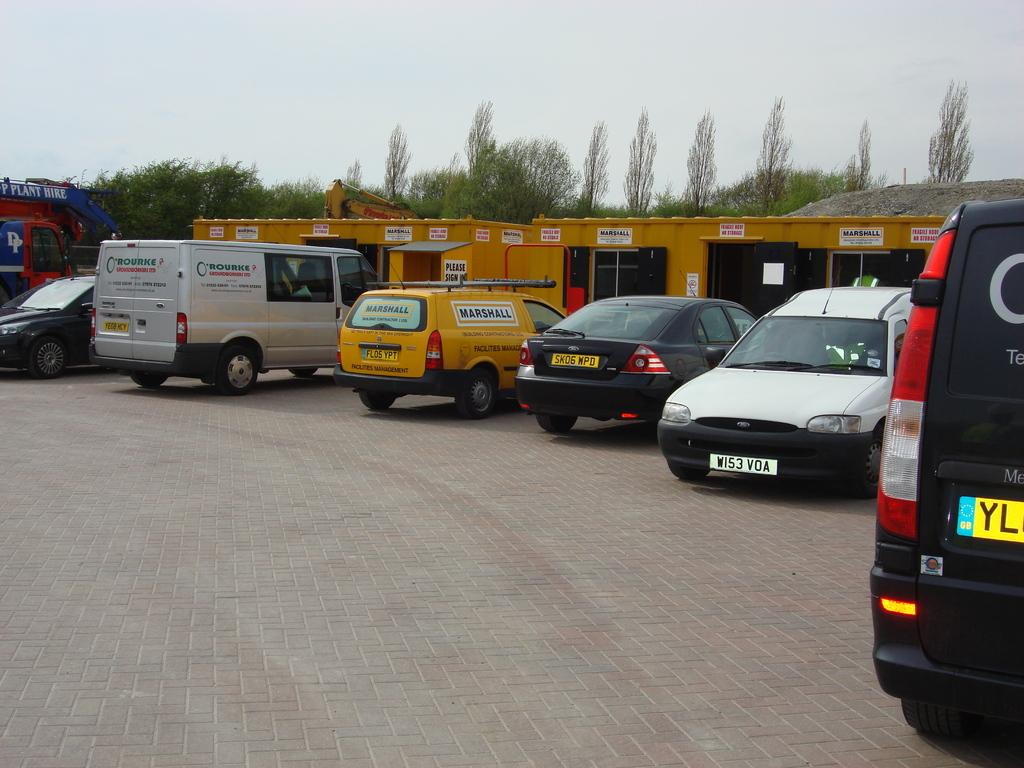<image>
Give a short and clear explanation of the subsequent image. A Marshall facilities management van is sitting in the parking pot with other vehicles. 